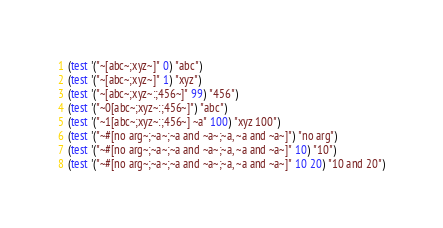Convert code to text. <code><loc_0><loc_0><loc_500><loc_500><_Scheme_>(test '("~[abc~;xyz~]" 0) "abc")
(test '("~[abc~;xyz~]" 1) "xyz")
(test '("~[abc~;xyz~:;456~]" 99) "456")
(test '("~0[abc~;xyz~:;456~]") "abc")
(test '("~1[abc~;xyz~:;456~] ~a" 100) "xyz 100")
(test '("~#[no arg~;~a~;~a and ~a~;~a, ~a and ~a~]") "no arg")
(test '("~#[no arg~;~a~;~a and ~a~;~a, ~a and ~a~]" 10) "10")
(test '("~#[no arg~;~a~;~a and ~a~;~a, ~a and ~a~]" 10 20) "10 and 20")</code> 